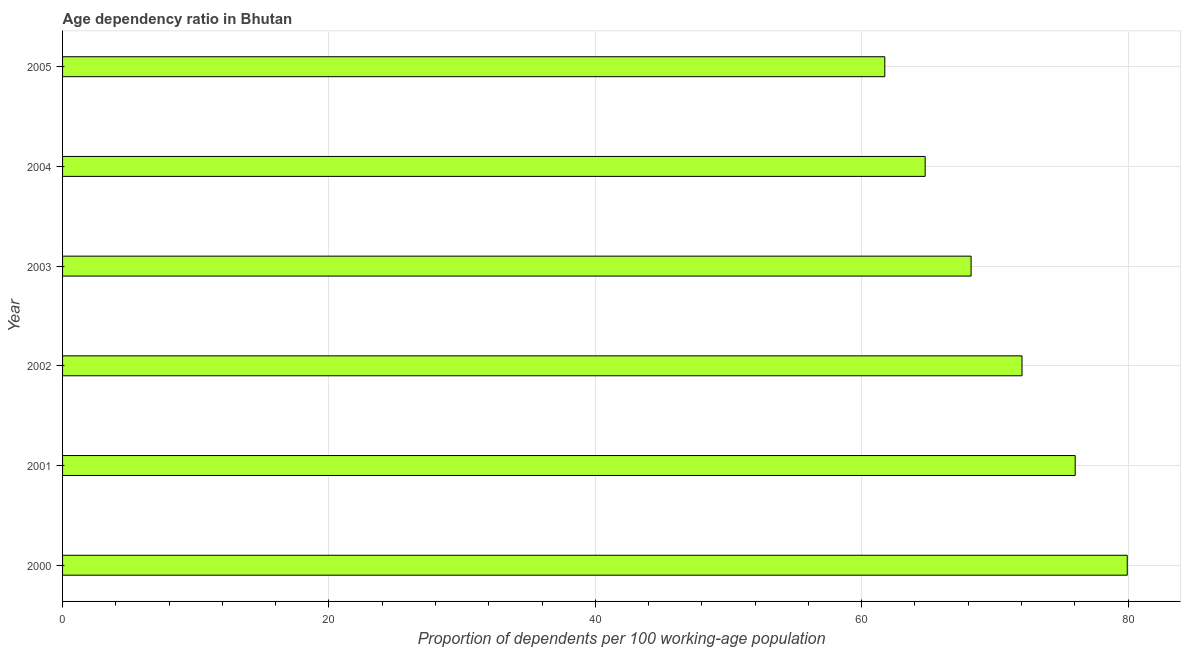Does the graph contain any zero values?
Your answer should be compact. No. Does the graph contain grids?
Offer a very short reply. Yes. What is the title of the graph?
Make the answer very short. Age dependency ratio in Bhutan. What is the label or title of the X-axis?
Provide a short and direct response. Proportion of dependents per 100 working-age population. What is the age dependency ratio in 2005?
Provide a succinct answer. 61.73. Across all years, what is the maximum age dependency ratio?
Give a very brief answer. 79.94. Across all years, what is the minimum age dependency ratio?
Provide a short and direct response. 61.73. What is the sum of the age dependency ratio?
Provide a succinct answer. 422.71. What is the difference between the age dependency ratio in 2002 and 2005?
Your response must be concise. 10.3. What is the average age dependency ratio per year?
Offer a terse response. 70.45. What is the median age dependency ratio?
Give a very brief answer. 70.12. In how many years, is the age dependency ratio greater than 32 ?
Ensure brevity in your answer.  6. What is the ratio of the age dependency ratio in 2004 to that in 2005?
Your response must be concise. 1.05. Is the age dependency ratio in 2002 less than that in 2005?
Provide a succinct answer. No. Is the difference between the age dependency ratio in 2000 and 2005 greater than the difference between any two years?
Keep it short and to the point. Yes. What is the difference between the highest and the second highest age dependency ratio?
Your answer should be compact. 3.91. What is the difference between the highest and the lowest age dependency ratio?
Make the answer very short. 18.2. In how many years, is the age dependency ratio greater than the average age dependency ratio taken over all years?
Your answer should be very brief. 3. How many bars are there?
Offer a very short reply. 6. Are all the bars in the graph horizontal?
Ensure brevity in your answer.  Yes. How many years are there in the graph?
Your response must be concise. 6. What is the difference between two consecutive major ticks on the X-axis?
Ensure brevity in your answer.  20. What is the Proportion of dependents per 100 working-age population in 2000?
Make the answer very short. 79.94. What is the Proportion of dependents per 100 working-age population in 2001?
Provide a succinct answer. 76.03. What is the Proportion of dependents per 100 working-age population of 2002?
Provide a succinct answer. 72.04. What is the Proportion of dependents per 100 working-age population of 2003?
Provide a short and direct response. 68.21. What is the Proportion of dependents per 100 working-age population in 2004?
Give a very brief answer. 64.76. What is the Proportion of dependents per 100 working-age population in 2005?
Offer a very short reply. 61.73. What is the difference between the Proportion of dependents per 100 working-age population in 2000 and 2001?
Your answer should be very brief. 3.91. What is the difference between the Proportion of dependents per 100 working-age population in 2000 and 2002?
Your answer should be very brief. 7.9. What is the difference between the Proportion of dependents per 100 working-age population in 2000 and 2003?
Your response must be concise. 11.72. What is the difference between the Proportion of dependents per 100 working-age population in 2000 and 2004?
Your answer should be very brief. 15.17. What is the difference between the Proportion of dependents per 100 working-age population in 2000 and 2005?
Offer a terse response. 18.2. What is the difference between the Proportion of dependents per 100 working-age population in 2001 and 2002?
Provide a succinct answer. 3.99. What is the difference between the Proportion of dependents per 100 working-age population in 2001 and 2003?
Offer a terse response. 7.82. What is the difference between the Proportion of dependents per 100 working-age population in 2001 and 2004?
Your answer should be compact. 11.26. What is the difference between the Proportion of dependents per 100 working-age population in 2001 and 2005?
Your answer should be very brief. 14.3. What is the difference between the Proportion of dependents per 100 working-age population in 2002 and 2003?
Make the answer very short. 3.82. What is the difference between the Proportion of dependents per 100 working-age population in 2002 and 2004?
Your response must be concise. 7.27. What is the difference between the Proportion of dependents per 100 working-age population in 2002 and 2005?
Your answer should be very brief. 10.3. What is the difference between the Proportion of dependents per 100 working-age population in 2003 and 2004?
Your answer should be compact. 3.45. What is the difference between the Proportion of dependents per 100 working-age population in 2003 and 2005?
Ensure brevity in your answer.  6.48. What is the difference between the Proportion of dependents per 100 working-age population in 2004 and 2005?
Give a very brief answer. 3.03. What is the ratio of the Proportion of dependents per 100 working-age population in 2000 to that in 2001?
Your response must be concise. 1.05. What is the ratio of the Proportion of dependents per 100 working-age population in 2000 to that in 2002?
Give a very brief answer. 1.11. What is the ratio of the Proportion of dependents per 100 working-age population in 2000 to that in 2003?
Your answer should be very brief. 1.17. What is the ratio of the Proportion of dependents per 100 working-age population in 2000 to that in 2004?
Make the answer very short. 1.23. What is the ratio of the Proportion of dependents per 100 working-age population in 2000 to that in 2005?
Offer a terse response. 1.29. What is the ratio of the Proportion of dependents per 100 working-age population in 2001 to that in 2002?
Provide a short and direct response. 1.05. What is the ratio of the Proportion of dependents per 100 working-age population in 2001 to that in 2003?
Offer a terse response. 1.11. What is the ratio of the Proportion of dependents per 100 working-age population in 2001 to that in 2004?
Keep it short and to the point. 1.17. What is the ratio of the Proportion of dependents per 100 working-age population in 2001 to that in 2005?
Offer a very short reply. 1.23. What is the ratio of the Proportion of dependents per 100 working-age population in 2002 to that in 2003?
Ensure brevity in your answer.  1.06. What is the ratio of the Proportion of dependents per 100 working-age population in 2002 to that in 2004?
Give a very brief answer. 1.11. What is the ratio of the Proportion of dependents per 100 working-age population in 2002 to that in 2005?
Ensure brevity in your answer.  1.17. What is the ratio of the Proportion of dependents per 100 working-age population in 2003 to that in 2004?
Offer a terse response. 1.05. What is the ratio of the Proportion of dependents per 100 working-age population in 2003 to that in 2005?
Your answer should be very brief. 1.1. What is the ratio of the Proportion of dependents per 100 working-age population in 2004 to that in 2005?
Provide a succinct answer. 1.05. 